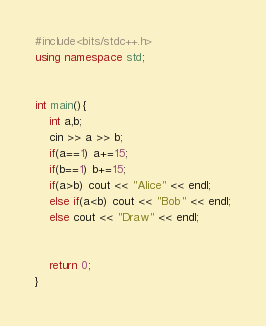Convert code to text. <code><loc_0><loc_0><loc_500><loc_500><_C++_>#include<bits/stdc++.h>
using namespace std;


int main(){
	int a,b;
	cin >> a >> b;
	if(a==1) a+=15;
	if(b==1) b+=15;
	if(a>b) cout << "Alice" << endl;
	else if(a<b) cout << "Bob" << endl;
	else cout << "Draw" << endl;


	return 0;
}</code> 